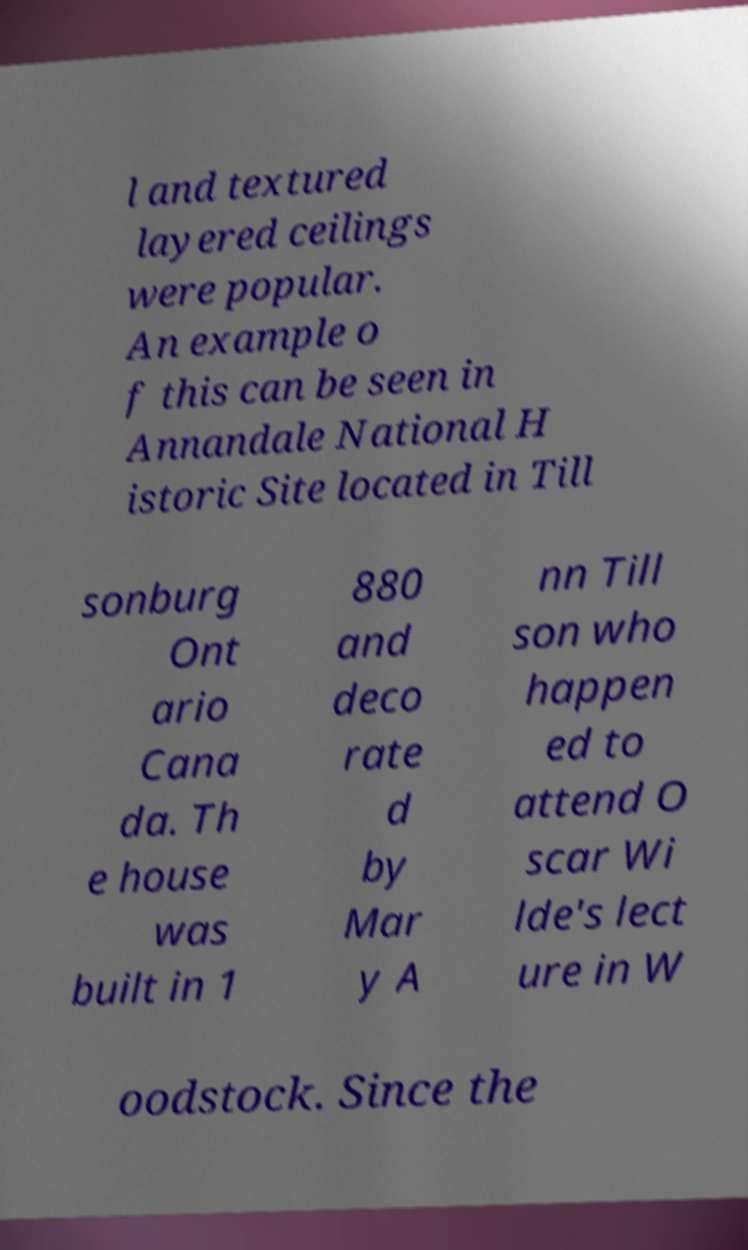Could you extract and type out the text from this image? l and textured layered ceilings were popular. An example o f this can be seen in Annandale National H istoric Site located in Till sonburg Ont ario Cana da. Th e house was built in 1 880 and deco rate d by Mar y A nn Till son who happen ed to attend O scar Wi lde's lect ure in W oodstock. Since the 